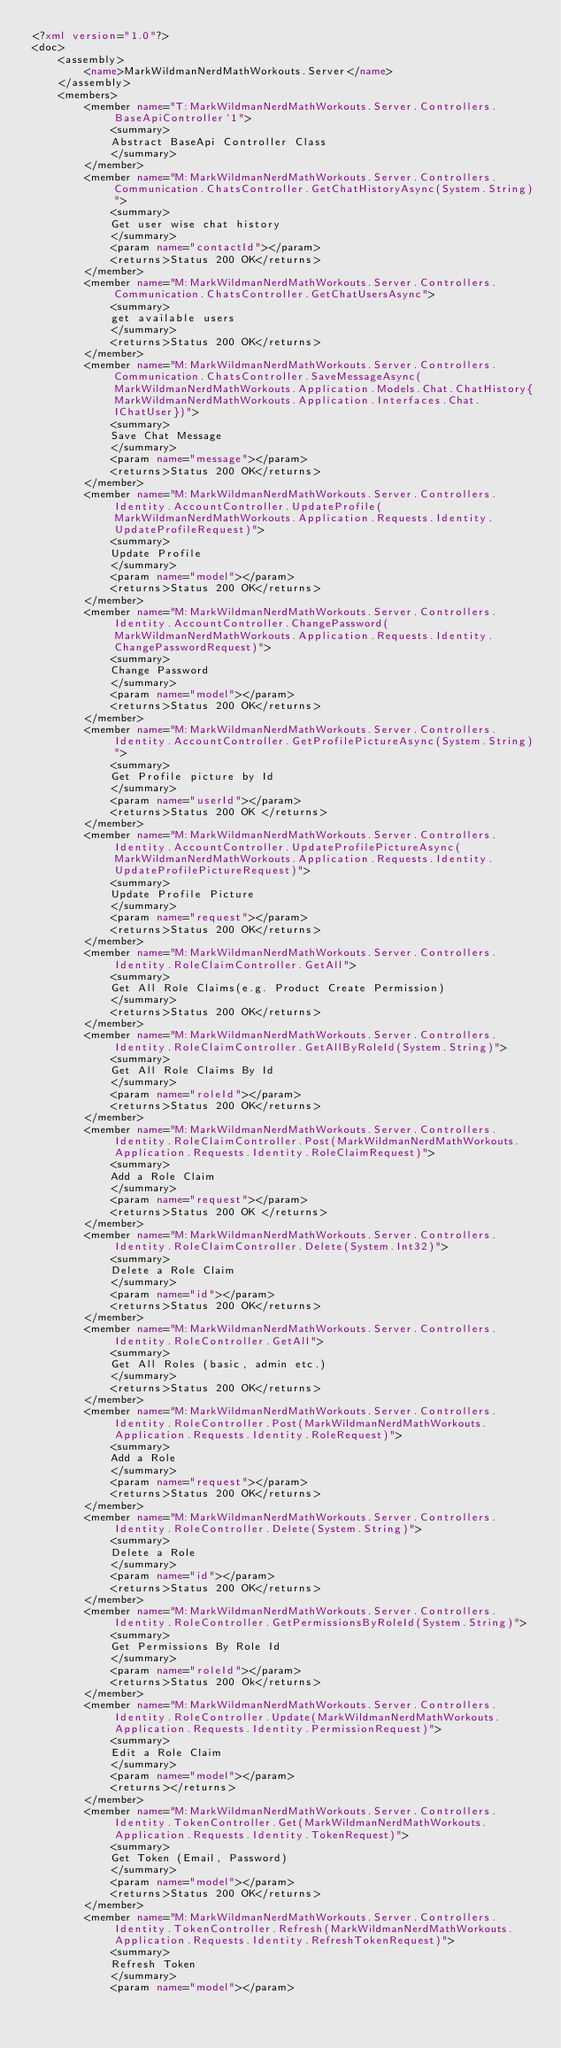Convert code to text. <code><loc_0><loc_0><loc_500><loc_500><_XML_><?xml version="1.0"?>
<doc>
    <assembly>
        <name>MarkWildmanNerdMathWorkouts.Server</name>
    </assembly>
    <members>
        <member name="T:MarkWildmanNerdMathWorkouts.Server.Controllers.BaseApiController`1">
            <summary>
            Abstract BaseApi Controller Class
            </summary>
        </member>
        <member name="M:MarkWildmanNerdMathWorkouts.Server.Controllers.Communication.ChatsController.GetChatHistoryAsync(System.String)">
            <summary>
            Get user wise chat history
            </summary>
            <param name="contactId"></param>
            <returns>Status 200 OK</returns>
        </member>
        <member name="M:MarkWildmanNerdMathWorkouts.Server.Controllers.Communication.ChatsController.GetChatUsersAsync">
            <summary>
            get available users
            </summary>
            <returns>Status 200 OK</returns>
        </member>
        <member name="M:MarkWildmanNerdMathWorkouts.Server.Controllers.Communication.ChatsController.SaveMessageAsync(MarkWildmanNerdMathWorkouts.Application.Models.Chat.ChatHistory{MarkWildmanNerdMathWorkouts.Application.Interfaces.Chat.IChatUser})">
            <summary>
            Save Chat Message
            </summary>
            <param name="message"></param>
            <returns>Status 200 OK</returns>
        </member>
        <member name="M:MarkWildmanNerdMathWorkouts.Server.Controllers.Identity.AccountController.UpdateProfile(MarkWildmanNerdMathWorkouts.Application.Requests.Identity.UpdateProfileRequest)">
            <summary>
            Update Profile
            </summary>
            <param name="model"></param>
            <returns>Status 200 OK</returns>
        </member>
        <member name="M:MarkWildmanNerdMathWorkouts.Server.Controllers.Identity.AccountController.ChangePassword(MarkWildmanNerdMathWorkouts.Application.Requests.Identity.ChangePasswordRequest)">
            <summary>
            Change Password
            </summary>
            <param name="model"></param>
            <returns>Status 200 OK</returns>
        </member>
        <member name="M:MarkWildmanNerdMathWorkouts.Server.Controllers.Identity.AccountController.GetProfilePictureAsync(System.String)">
            <summary>
            Get Profile picture by Id
            </summary>
            <param name="userId"></param>
            <returns>Status 200 OK </returns>
        </member>
        <member name="M:MarkWildmanNerdMathWorkouts.Server.Controllers.Identity.AccountController.UpdateProfilePictureAsync(MarkWildmanNerdMathWorkouts.Application.Requests.Identity.UpdateProfilePictureRequest)">
            <summary>
            Update Profile Picture
            </summary>
            <param name="request"></param>
            <returns>Status 200 OK</returns>
        </member>
        <member name="M:MarkWildmanNerdMathWorkouts.Server.Controllers.Identity.RoleClaimController.GetAll">
            <summary>
            Get All Role Claims(e.g. Product Create Permission)
            </summary>
            <returns>Status 200 OK</returns>
        </member>
        <member name="M:MarkWildmanNerdMathWorkouts.Server.Controllers.Identity.RoleClaimController.GetAllByRoleId(System.String)">
            <summary>
            Get All Role Claims By Id
            </summary>
            <param name="roleId"></param>
            <returns>Status 200 OK</returns>
        </member>
        <member name="M:MarkWildmanNerdMathWorkouts.Server.Controllers.Identity.RoleClaimController.Post(MarkWildmanNerdMathWorkouts.Application.Requests.Identity.RoleClaimRequest)">
            <summary>
            Add a Role Claim
            </summary>
            <param name="request"></param>
            <returns>Status 200 OK </returns>
        </member>
        <member name="M:MarkWildmanNerdMathWorkouts.Server.Controllers.Identity.RoleClaimController.Delete(System.Int32)">
            <summary>
            Delete a Role Claim
            </summary>
            <param name="id"></param>
            <returns>Status 200 OK</returns>
        </member>
        <member name="M:MarkWildmanNerdMathWorkouts.Server.Controllers.Identity.RoleController.GetAll">
            <summary>
            Get All Roles (basic, admin etc.)
            </summary>
            <returns>Status 200 OK</returns>
        </member>
        <member name="M:MarkWildmanNerdMathWorkouts.Server.Controllers.Identity.RoleController.Post(MarkWildmanNerdMathWorkouts.Application.Requests.Identity.RoleRequest)">
            <summary>
            Add a Role
            </summary>
            <param name="request"></param>
            <returns>Status 200 OK</returns>
        </member>
        <member name="M:MarkWildmanNerdMathWorkouts.Server.Controllers.Identity.RoleController.Delete(System.String)">
            <summary>
            Delete a Role
            </summary>
            <param name="id"></param>
            <returns>Status 200 OK</returns>
        </member>
        <member name="M:MarkWildmanNerdMathWorkouts.Server.Controllers.Identity.RoleController.GetPermissionsByRoleId(System.String)">
            <summary>
            Get Permissions By Role Id
            </summary>
            <param name="roleId"></param>
            <returns>Status 200 Ok</returns>
        </member>
        <member name="M:MarkWildmanNerdMathWorkouts.Server.Controllers.Identity.RoleController.Update(MarkWildmanNerdMathWorkouts.Application.Requests.Identity.PermissionRequest)">
            <summary>
            Edit a Role Claim
            </summary>
            <param name="model"></param>
            <returns></returns>
        </member>
        <member name="M:MarkWildmanNerdMathWorkouts.Server.Controllers.Identity.TokenController.Get(MarkWildmanNerdMathWorkouts.Application.Requests.Identity.TokenRequest)">
            <summary>
            Get Token (Email, Password)
            </summary>
            <param name="model"></param>
            <returns>Status 200 OK</returns>
        </member>
        <member name="M:MarkWildmanNerdMathWorkouts.Server.Controllers.Identity.TokenController.Refresh(MarkWildmanNerdMathWorkouts.Application.Requests.Identity.RefreshTokenRequest)">
            <summary>
            Refresh Token
            </summary>
            <param name="model"></param></code> 